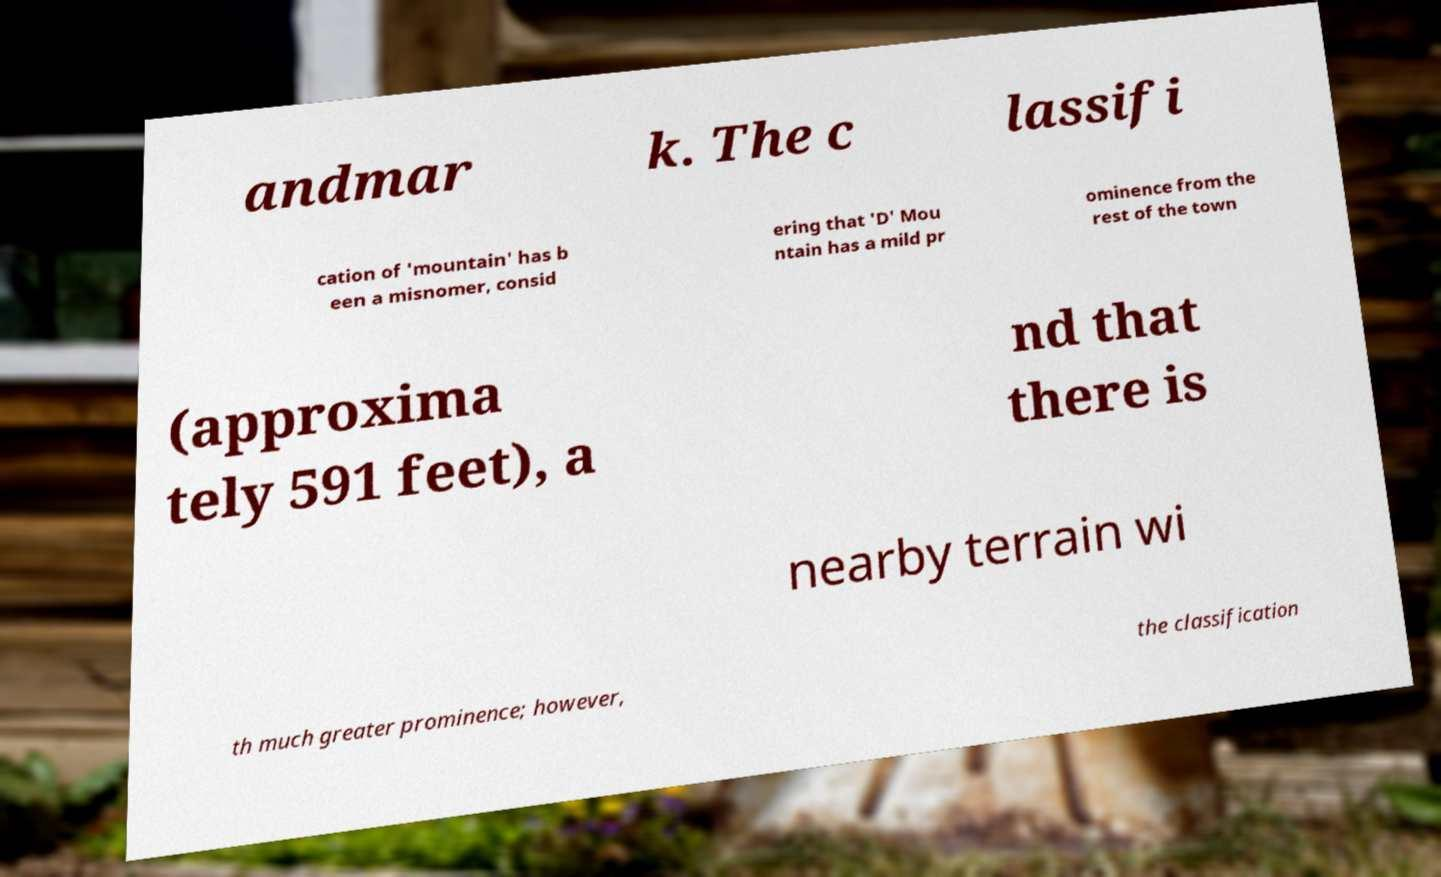Can you accurately transcribe the text from the provided image for me? andmar k. The c lassifi cation of 'mountain' has b een a misnomer, consid ering that 'D' Mou ntain has a mild pr ominence from the rest of the town (approxima tely 591 feet), a nd that there is nearby terrain wi th much greater prominence; however, the classification 